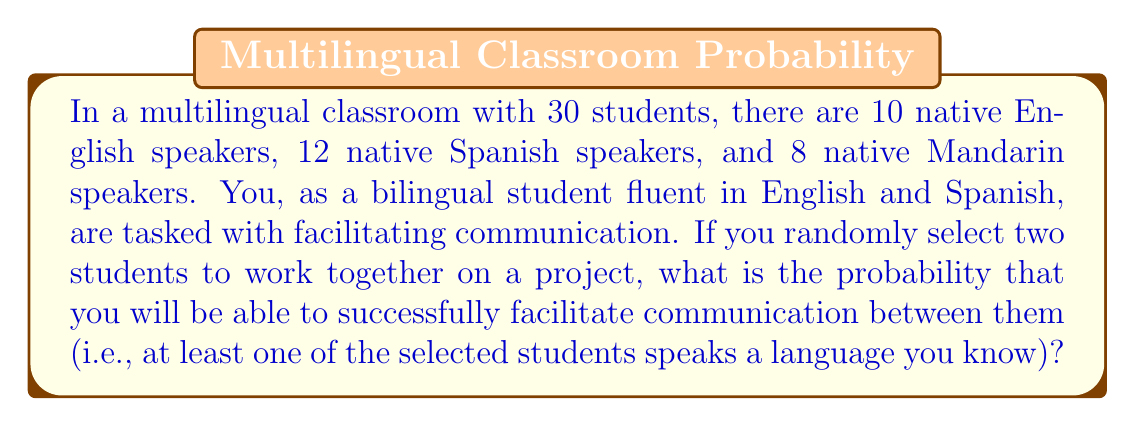Help me with this question. Let's approach this step-by-step:

1) First, we need to calculate the total number of possible pairs of students:
   $$\binom{30}{2} = \frac{30!}{2!(30-2)!} = \frac{30 \cdot 29}{2} = 435$$

2) Now, we need to calculate the number of pairs where communication would fail. This would occur when both selected students are Mandarin speakers:
   $$\binom{8}{2} = \frac{8!}{2!(8-2)!} = \frac{8 \cdot 7}{2} = 28$$

3) The probability of successful communication is the complement of the probability of failed communication:

   $$P(\text{success}) = 1 - P(\text{fail})$$

4) We can calculate this as:

   $$P(\text{success}) = 1 - \frac{\text{number of failing pairs}}{\text{total number of pairs}}$$

5) Plugging in our numbers:

   $$P(\text{success}) = 1 - \frac{28}{435} = \frac{435 - 28}{435} = \frac{407}{435}$$

6) This fraction can be reduced to:

   $$\frac{407}{435} = \frac{37}{39} \approx 0.9487$$
Answer: The probability of successful communication is $\frac{37}{39}$ or approximately 0.9487 (94.87%). 